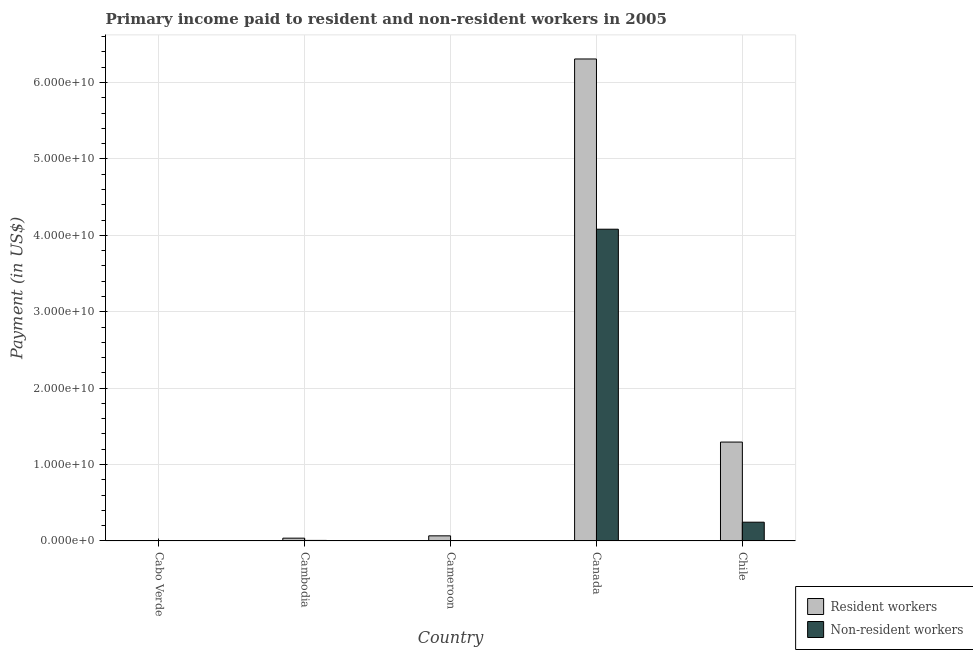How many different coloured bars are there?
Keep it short and to the point. 2. How many groups of bars are there?
Provide a succinct answer. 5. How many bars are there on the 3rd tick from the left?
Your answer should be compact. 2. In how many cases, is the number of bars for a given country not equal to the number of legend labels?
Offer a terse response. 0. What is the payment made to resident workers in Canada?
Provide a succinct answer. 6.31e+1. Across all countries, what is the maximum payment made to resident workers?
Your answer should be compact. 6.31e+1. Across all countries, what is the minimum payment made to non-resident workers?
Offer a very short reply. 1.92e+07. In which country was the payment made to non-resident workers maximum?
Make the answer very short. Canada. In which country was the payment made to non-resident workers minimum?
Offer a terse response. Cabo Verde. What is the total payment made to resident workers in the graph?
Your response must be concise. 7.71e+1. What is the difference between the payment made to non-resident workers in Cabo Verde and that in Canada?
Your answer should be very brief. -4.08e+1. What is the difference between the payment made to resident workers in Cambodia and the payment made to non-resident workers in Canada?
Provide a succinct answer. -4.04e+1. What is the average payment made to resident workers per country?
Provide a short and direct response. 1.54e+1. What is the difference between the payment made to non-resident workers and payment made to resident workers in Canada?
Make the answer very short. -2.23e+1. What is the ratio of the payment made to resident workers in Cameroon to that in Canada?
Provide a succinct answer. 0.01. What is the difference between the highest and the second highest payment made to non-resident workers?
Keep it short and to the point. 3.83e+1. What is the difference between the highest and the lowest payment made to resident workers?
Ensure brevity in your answer.  6.30e+1. Is the sum of the payment made to non-resident workers in Cabo Verde and Canada greater than the maximum payment made to resident workers across all countries?
Provide a succinct answer. No. What does the 1st bar from the left in Cameroon represents?
Provide a succinct answer. Resident workers. What does the 2nd bar from the right in Cabo Verde represents?
Offer a very short reply. Resident workers. How many bars are there?
Your response must be concise. 10. What is the difference between two consecutive major ticks on the Y-axis?
Offer a terse response. 1.00e+1. Does the graph contain any zero values?
Keep it short and to the point. No. Does the graph contain grids?
Offer a very short reply. Yes. What is the title of the graph?
Offer a very short reply. Primary income paid to resident and non-resident workers in 2005. Does "Urban" appear as one of the legend labels in the graph?
Your answer should be very brief. No. What is the label or title of the X-axis?
Your response must be concise. Country. What is the label or title of the Y-axis?
Offer a very short reply. Payment (in US$). What is the Payment (in US$) in Resident workers in Cabo Verde?
Offer a terse response. 5.27e+07. What is the Payment (in US$) of Non-resident workers in Cabo Verde?
Provide a short and direct response. 1.92e+07. What is the Payment (in US$) in Resident workers in Cambodia?
Provide a succinct answer. 3.61e+08. What is the Payment (in US$) of Non-resident workers in Cambodia?
Make the answer very short. 6.77e+07. What is the Payment (in US$) of Resident workers in Cameroon?
Provide a succinct answer. 6.65e+08. What is the Payment (in US$) in Non-resident workers in Cameroon?
Ensure brevity in your answer.  4.49e+07. What is the Payment (in US$) of Resident workers in Canada?
Your answer should be compact. 6.31e+1. What is the Payment (in US$) in Non-resident workers in Canada?
Provide a succinct answer. 4.08e+1. What is the Payment (in US$) of Resident workers in Chile?
Your response must be concise. 1.29e+1. What is the Payment (in US$) of Non-resident workers in Chile?
Provide a short and direct response. 2.45e+09. Across all countries, what is the maximum Payment (in US$) in Resident workers?
Your answer should be very brief. 6.31e+1. Across all countries, what is the maximum Payment (in US$) of Non-resident workers?
Ensure brevity in your answer.  4.08e+1. Across all countries, what is the minimum Payment (in US$) of Resident workers?
Ensure brevity in your answer.  5.27e+07. Across all countries, what is the minimum Payment (in US$) of Non-resident workers?
Provide a short and direct response. 1.92e+07. What is the total Payment (in US$) in Resident workers in the graph?
Offer a terse response. 7.71e+1. What is the total Payment (in US$) in Non-resident workers in the graph?
Offer a terse response. 4.34e+1. What is the difference between the Payment (in US$) of Resident workers in Cabo Verde and that in Cambodia?
Offer a terse response. -3.08e+08. What is the difference between the Payment (in US$) of Non-resident workers in Cabo Verde and that in Cambodia?
Your answer should be very brief. -4.85e+07. What is the difference between the Payment (in US$) in Resident workers in Cabo Verde and that in Cameroon?
Your answer should be very brief. -6.13e+08. What is the difference between the Payment (in US$) of Non-resident workers in Cabo Verde and that in Cameroon?
Ensure brevity in your answer.  -2.57e+07. What is the difference between the Payment (in US$) of Resident workers in Cabo Verde and that in Canada?
Keep it short and to the point. -6.30e+1. What is the difference between the Payment (in US$) of Non-resident workers in Cabo Verde and that in Canada?
Your answer should be very brief. -4.08e+1. What is the difference between the Payment (in US$) of Resident workers in Cabo Verde and that in Chile?
Give a very brief answer. -1.29e+1. What is the difference between the Payment (in US$) in Non-resident workers in Cabo Verde and that in Chile?
Provide a short and direct response. -2.43e+09. What is the difference between the Payment (in US$) of Resident workers in Cambodia and that in Cameroon?
Keep it short and to the point. -3.04e+08. What is the difference between the Payment (in US$) in Non-resident workers in Cambodia and that in Cameroon?
Provide a succinct answer. 2.28e+07. What is the difference between the Payment (in US$) of Resident workers in Cambodia and that in Canada?
Give a very brief answer. -6.27e+1. What is the difference between the Payment (in US$) in Non-resident workers in Cambodia and that in Canada?
Provide a succinct answer. -4.07e+1. What is the difference between the Payment (in US$) of Resident workers in Cambodia and that in Chile?
Keep it short and to the point. -1.26e+1. What is the difference between the Payment (in US$) in Non-resident workers in Cambodia and that in Chile?
Offer a terse response. -2.38e+09. What is the difference between the Payment (in US$) of Resident workers in Cameroon and that in Canada?
Provide a short and direct response. -6.24e+1. What is the difference between the Payment (in US$) of Non-resident workers in Cameroon and that in Canada?
Provide a succinct answer. -4.08e+1. What is the difference between the Payment (in US$) in Resident workers in Cameroon and that in Chile?
Give a very brief answer. -1.23e+1. What is the difference between the Payment (in US$) of Non-resident workers in Cameroon and that in Chile?
Your answer should be very brief. -2.41e+09. What is the difference between the Payment (in US$) of Resident workers in Canada and that in Chile?
Offer a very short reply. 5.01e+1. What is the difference between the Payment (in US$) in Non-resident workers in Canada and that in Chile?
Ensure brevity in your answer.  3.83e+1. What is the difference between the Payment (in US$) of Resident workers in Cabo Verde and the Payment (in US$) of Non-resident workers in Cambodia?
Make the answer very short. -1.50e+07. What is the difference between the Payment (in US$) in Resident workers in Cabo Verde and the Payment (in US$) in Non-resident workers in Cameroon?
Your response must be concise. 7.78e+06. What is the difference between the Payment (in US$) in Resident workers in Cabo Verde and the Payment (in US$) in Non-resident workers in Canada?
Your answer should be compact. -4.07e+1. What is the difference between the Payment (in US$) of Resident workers in Cabo Verde and the Payment (in US$) of Non-resident workers in Chile?
Provide a short and direct response. -2.40e+09. What is the difference between the Payment (in US$) of Resident workers in Cambodia and the Payment (in US$) of Non-resident workers in Cameroon?
Make the answer very short. 3.16e+08. What is the difference between the Payment (in US$) of Resident workers in Cambodia and the Payment (in US$) of Non-resident workers in Canada?
Make the answer very short. -4.04e+1. What is the difference between the Payment (in US$) of Resident workers in Cambodia and the Payment (in US$) of Non-resident workers in Chile?
Offer a very short reply. -2.09e+09. What is the difference between the Payment (in US$) of Resident workers in Cameroon and the Payment (in US$) of Non-resident workers in Canada?
Make the answer very short. -4.01e+1. What is the difference between the Payment (in US$) of Resident workers in Cameroon and the Payment (in US$) of Non-resident workers in Chile?
Your response must be concise. -1.79e+09. What is the difference between the Payment (in US$) in Resident workers in Canada and the Payment (in US$) in Non-resident workers in Chile?
Keep it short and to the point. 6.06e+1. What is the average Payment (in US$) of Resident workers per country?
Make the answer very short. 1.54e+1. What is the average Payment (in US$) in Non-resident workers per country?
Make the answer very short. 8.68e+09. What is the difference between the Payment (in US$) in Resident workers and Payment (in US$) in Non-resident workers in Cabo Verde?
Your response must be concise. 3.35e+07. What is the difference between the Payment (in US$) in Resident workers and Payment (in US$) in Non-resident workers in Cambodia?
Provide a short and direct response. 2.93e+08. What is the difference between the Payment (in US$) in Resident workers and Payment (in US$) in Non-resident workers in Cameroon?
Offer a terse response. 6.20e+08. What is the difference between the Payment (in US$) of Resident workers and Payment (in US$) of Non-resident workers in Canada?
Offer a very short reply. 2.23e+1. What is the difference between the Payment (in US$) in Resident workers and Payment (in US$) in Non-resident workers in Chile?
Your answer should be very brief. 1.05e+1. What is the ratio of the Payment (in US$) in Resident workers in Cabo Verde to that in Cambodia?
Offer a very short reply. 0.15. What is the ratio of the Payment (in US$) in Non-resident workers in Cabo Verde to that in Cambodia?
Offer a terse response. 0.28. What is the ratio of the Payment (in US$) of Resident workers in Cabo Verde to that in Cameroon?
Offer a terse response. 0.08. What is the ratio of the Payment (in US$) of Non-resident workers in Cabo Verde to that in Cameroon?
Provide a succinct answer. 0.43. What is the ratio of the Payment (in US$) in Resident workers in Cabo Verde to that in Canada?
Your response must be concise. 0. What is the ratio of the Payment (in US$) in Non-resident workers in Cabo Verde to that in Canada?
Provide a short and direct response. 0. What is the ratio of the Payment (in US$) of Resident workers in Cabo Verde to that in Chile?
Keep it short and to the point. 0. What is the ratio of the Payment (in US$) of Non-resident workers in Cabo Verde to that in Chile?
Your response must be concise. 0.01. What is the ratio of the Payment (in US$) in Resident workers in Cambodia to that in Cameroon?
Keep it short and to the point. 0.54. What is the ratio of the Payment (in US$) in Non-resident workers in Cambodia to that in Cameroon?
Offer a very short reply. 1.51. What is the ratio of the Payment (in US$) of Resident workers in Cambodia to that in Canada?
Ensure brevity in your answer.  0.01. What is the ratio of the Payment (in US$) of Non-resident workers in Cambodia to that in Canada?
Make the answer very short. 0. What is the ratio of the Payment (in US$) of Resident workers in Cambodia to that in Chile?
Give a very brief answer. 0.03. What is the ratio of the Payment (in US$) in Non-resident workers in Cambodia to that in Chile?
Offer a very short reply. 0.03. What is the ratio of the Payment (in US$) in Resident workers in Cameroon to that in Canada?
Keep it short and to the point. 0.01. What is the ratio of the Payment (in US$) of Non-resident workers in Cameroon to that in Canada?
Give a very brief answer. 0. What is the ratio of the Payment (in US$) in Resident workers in Cameroon to that in Chile?
Ensure brevity in your answer.  0.05. What is the ratio of the Payment (in US$) in Non-resident workers in Cameroon to that in Chile?
Offer a very short reply. 0.02. What is the ratio of the Payment (in US$) in Resident workers in Canada to that in Chile?
Ensure brevity in your answer.  4.88. What is the ratio of the Payment (in US$) in Non-resident workers in Canada to that in Chile?
Offer a very short reply. 16.64. What is the difference between the highest and the second highest Payment (in US$) in Resident workers?
Offer a very short reply. 5.01e+1. What is the difference between the highest and the second highest Payment (in US$) in Non-resident workers?
Your answer should be compact. 3.83e+1. What is the difference between the highest and the lowest Payment (in US$) in Resident workers?
Ensure brevity in your answer.  6.30e+1. What is the difference between the highest and the lowest Payment (in US$) in Non-resident workers?
Keep it short and to the point. 4.08e+1. 